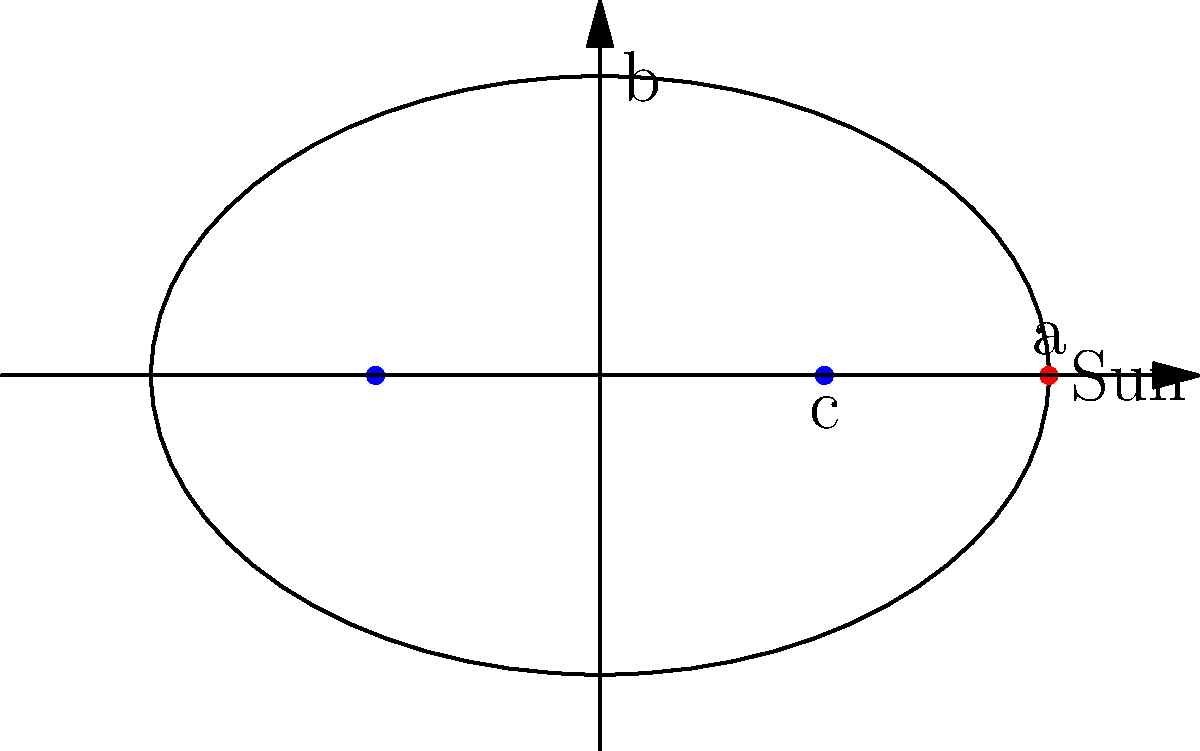Darling, as I struggle with my latest masterpiece, I can't help but ponder the cosmic ballet above. The planets' orbits around the Sun are like the chaotic swirls of paint on my canvas. Can you enlighten me about the relationship between the semi-major axis (a), semi-minor axis (b), and the distance from the center to a focus (c) in this celestial ellipse? Express your answer as an equation, please. It might inspire my next avant-garde creation! Oh, my dear tortured artist, let's unravel this cosmic mystery step by step:

1. In an elliptical orbit, the Sun is located at one of the foci.

2. The semi-major axis (a) is half the length of the ellipse's longest diameter.

3. The semi-minor axis (b) is half the length of the ellipse's shortest diameter.

4. The distance from the center to a focus (c) is related to a and b through the Pythagorean theorem:

   $$a^2 = b^2 + c^2$$

5. This equation can be rearranged to express c in terms of a and b:

   $$c^2 = a^2 - b^2$$

6. Taking the square root of both sides:

   $$c = \sqrt{a^2 - b^2}$$

This equation, my darling, is the cosmic truth you seek. It's like the golden ratio of the heavens, a perfect balance of form and function. Perhaps it will inspire you to create a series of elliptical masterpieces, each one a tribute to the dance of the planets!
Answer: $$c = \sqrt{a^2 - b^2}$$ 